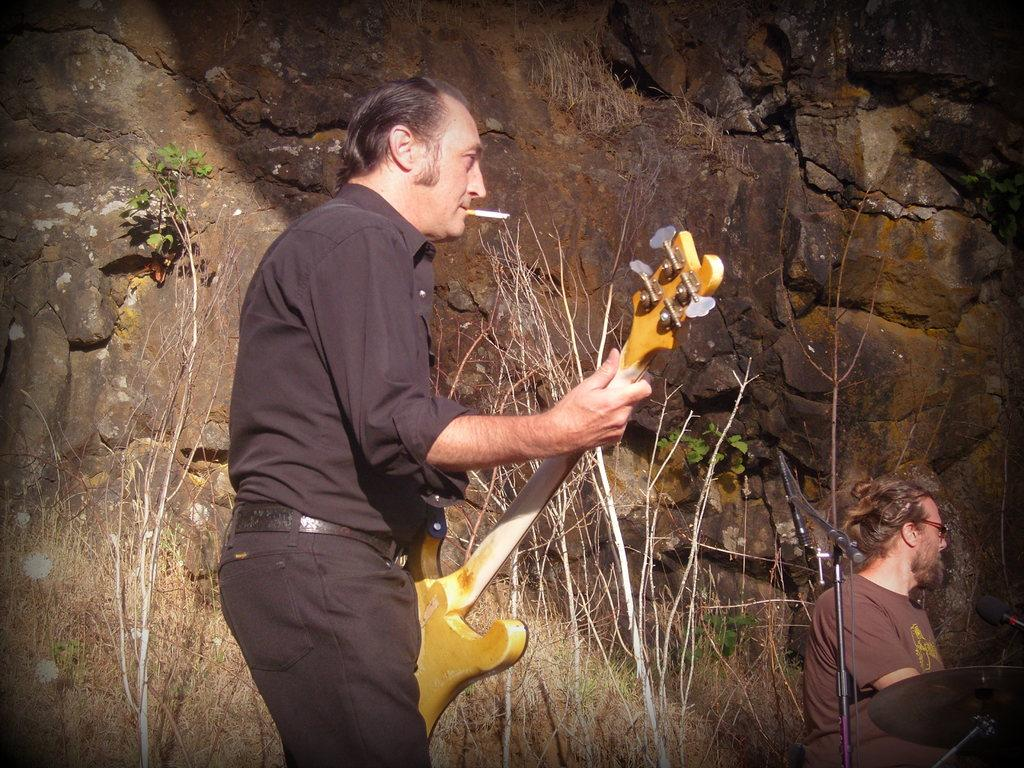What is the person in the image wearing? The person is wearing a black dress. What is the person holding in their hands? The person is holding a guitar in their hands. What can be seen in the person's mouth? The person has a cigarette in their mouth. Can you describe the background of the image? There is a person in the background of the image, and there are rocks present. What type of sponge can be seen floating in the air in the image? There is no sponge present in the image; it features a person holding a guitar and wearing a black dress. 